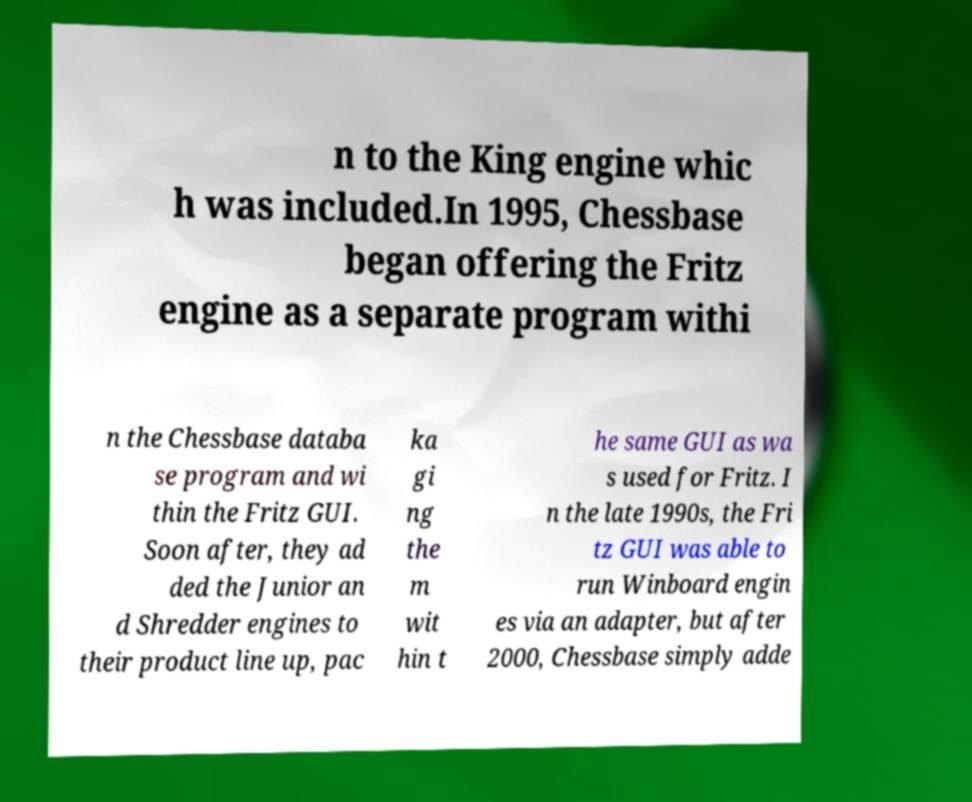For documentation purposes, I need the text within this image transcribed. Could you provide that? n to the King engine whic h was included.In 1995, Chessbase began offering the Fritz engine as a separate program withi n the Chessbase databa se program and wi thin the Fritz GUI. Soon after, they ad ded the Junior an d Shredder engines to their product line up, pac ka gi ng the m wit hin t he same GUI as wa s used for Fritz. I n the late 1990s, the Fri tz GUI was able to run Winboard engin es via an adapter, but after 2000, Chessbase simply adde 